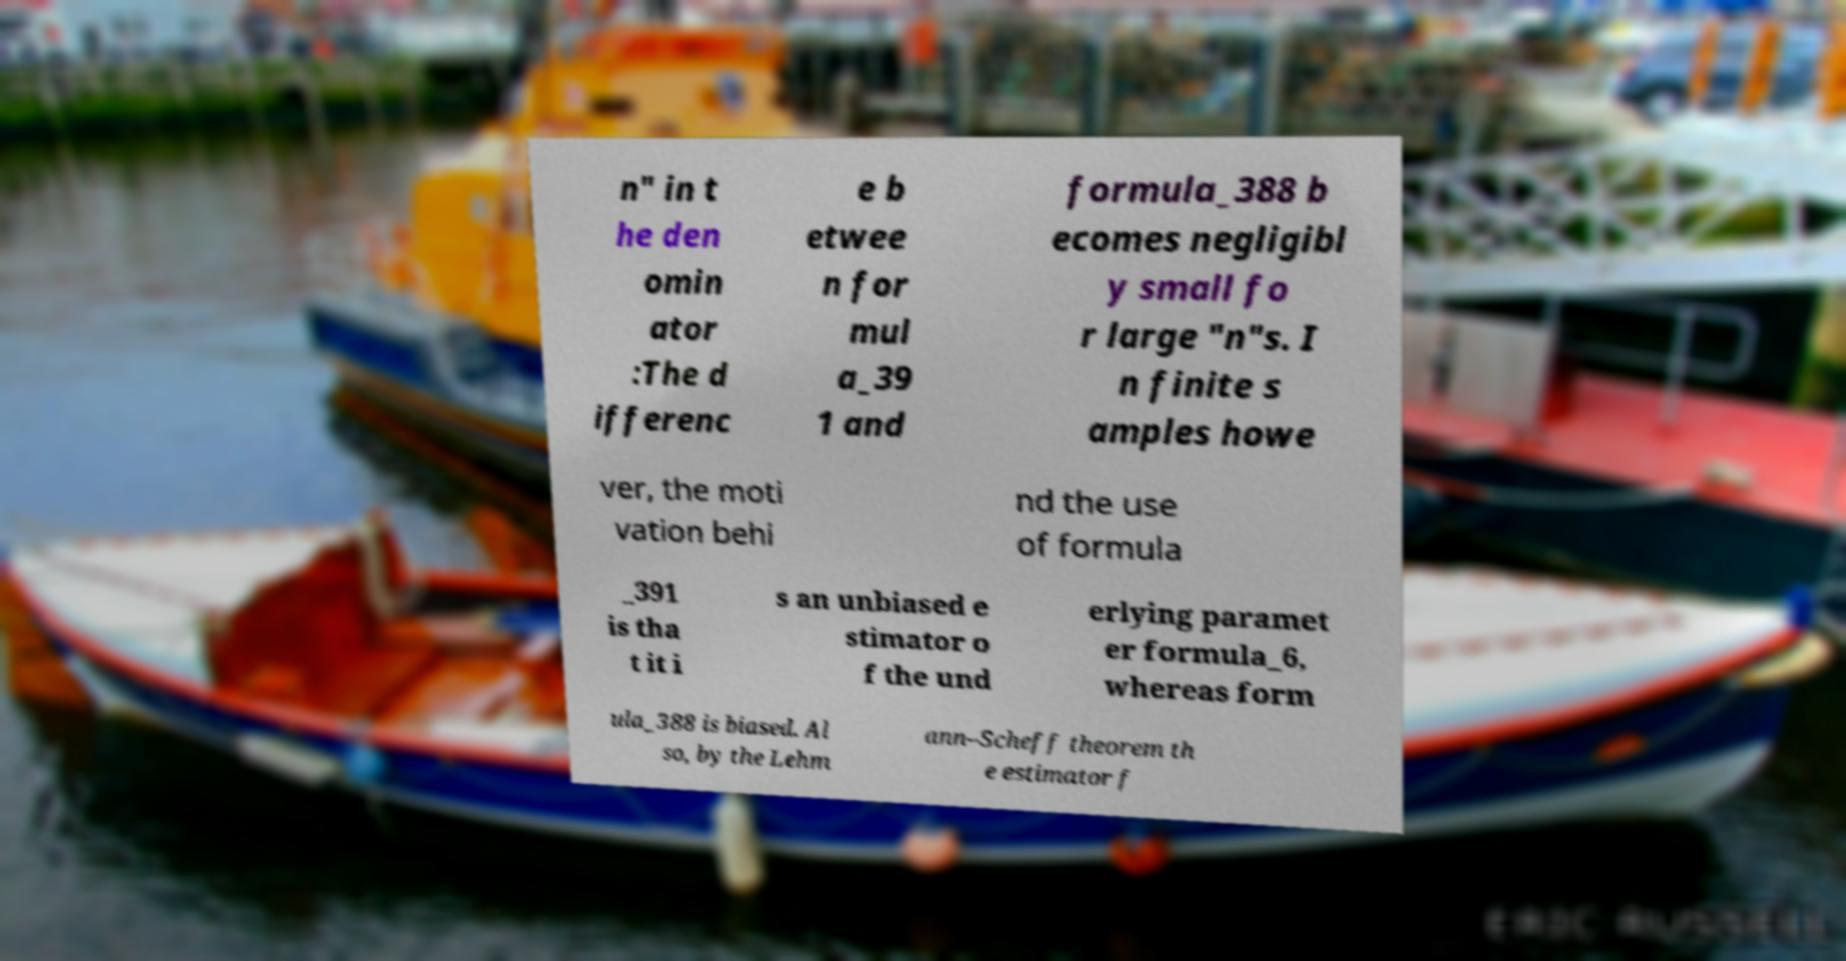What messages or text are displayed in this image? I need them in a readable, typed format. n" in t he den omin ator :The d ifferenc e b etwee n for mul a_39 1 and formula_388 b ecomes negligibl y small fo r large "n"s. I n finite s amples howe ver, the moti vation behi nd the use of formula _391 is tha t it i s an unbiased e stimator o f the und erlying paramet er formula_6, whereas form ula_388 is biased. Al so, by the Lehm ann–Scheff theorem th e estimator f 